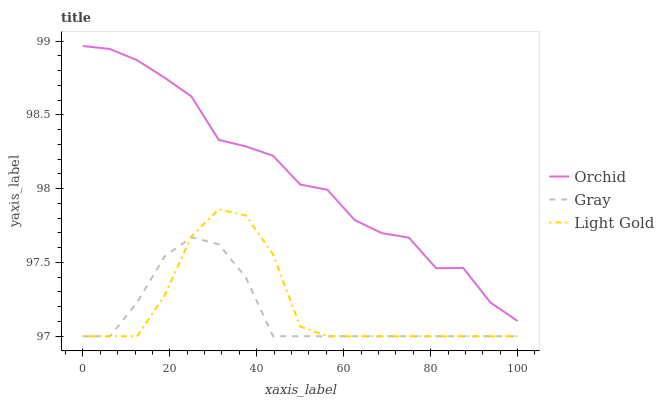Does Gray have the minimum area under the curve?
Answer yes or no. Yes. Does Orchid have the maximum area under the curve?
Answer yes or no. Yes. Does Light Gold have the minimum area under the curve?
Answer yes or no. No. Does Light Gold have the maximum area under the curve?
Answer yes or no. No. Is Gray the smoothest?
Answer yes or no. Yes. Is Orchid the roughest?
Answer yes or no. Yes. Is Light Gold the smoothest?
Answer yes or no. No. Is Light Gold the roughest?
Answer yes or no. No. Does Gray have the lowest value?
Answer yes or no. Yes. Does Orchid have the lowest value?
Answer yes or no. No. Does Orchid have the highest value?
Answer yes or no. Yes. Does Light Gold have the highest value?
Answer yes or no. No. Is Gray less than Orchid?
Answer yes or no. Yes. Is Orchid greater than Gray?
Answer yes or no. Yes. Does Light Gold intersect Gray?
Answer yes or no. Yes. Is Light Gold less than Gray?
Answer yes or no. No. Is Light Gold greater than Gray?
Answer yes or no. No. Does Gray intersect Orchid?
Answer yes or no. No. 